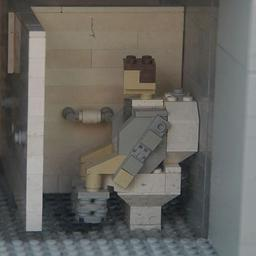What might be the purpose or message behind creating this Lego sculpture? The Lego sculpture, depicting a person in a washroom setting, cleverly uses the universally familiar medium of Lego to touch upon everyday privacy and self-care moments with a playful twist. It offers a whimsical reflection on daily life, suggesting that even the most mundane activities have aspects of fun and innovation. Additionally, this could be an artistic commentary on the importance of privacy and personal space depicted through a lighthearted, approachable form. 